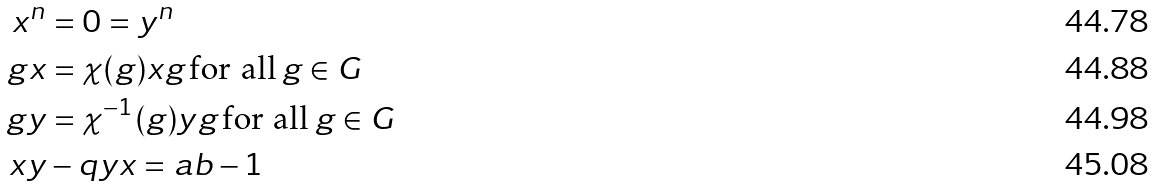<formula> <loc_0><loc_0><loc_500><loc_500>x ^ { n } & = 0 = y ^ { n } \\ g x & = \chi ( g ) x g \, \text {for all} \, g \in G \\ g y & = \chi ^ { - 1 } ( g ) y g \, \text {for all} \, g \in G \\ x y & - q y x = a b - 1</formula> 